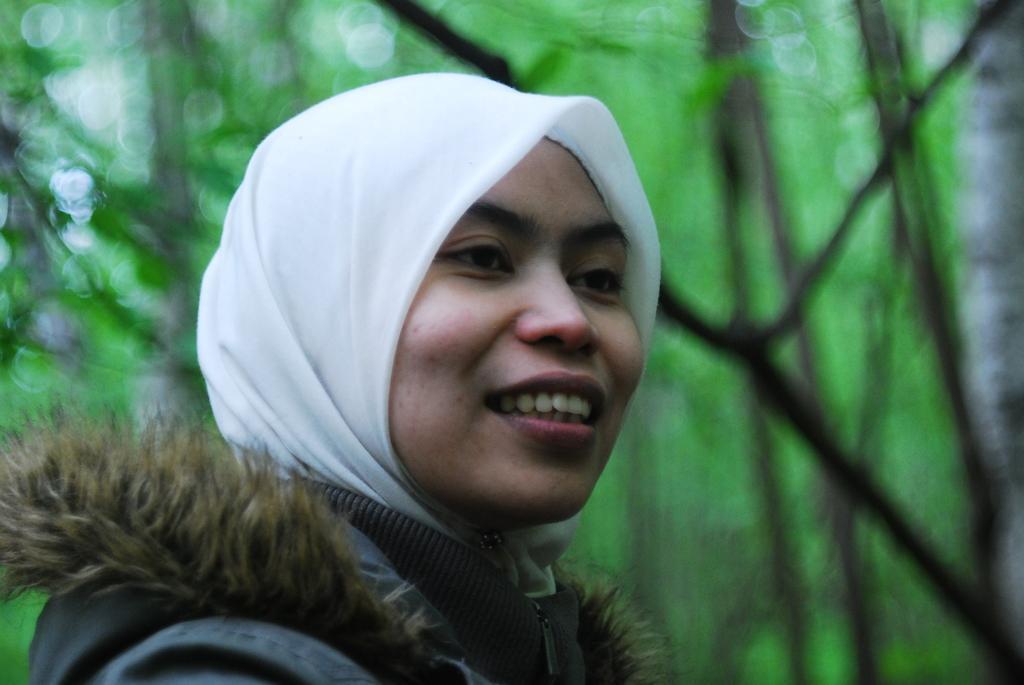Describe this image in one or two sentences. In the middle of the image we can see a woman smiling. Behind her we can see some trees. Background of the image is blur. 